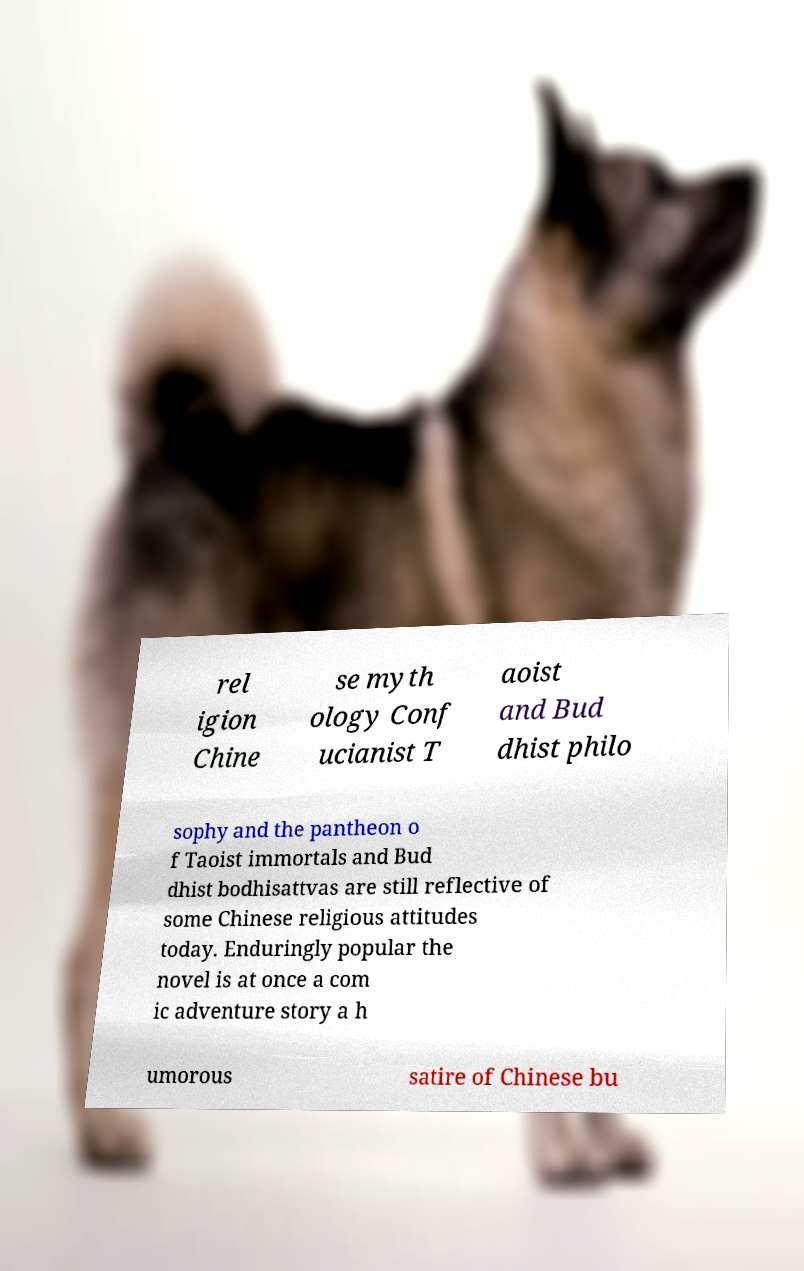Please read and relay the text visible in this image. What does it say? rel igion Chine se myth ology Conf ucianist T aoist and Bud dhist philo sophy and the pantheon o f Taoist immortals and Bud dhist bodhisattvas are still reflective of some Chinese religious attitudes today. Enduringly popular the novel is at once a com ic adventure story a h umorous satire of Chinese bu 